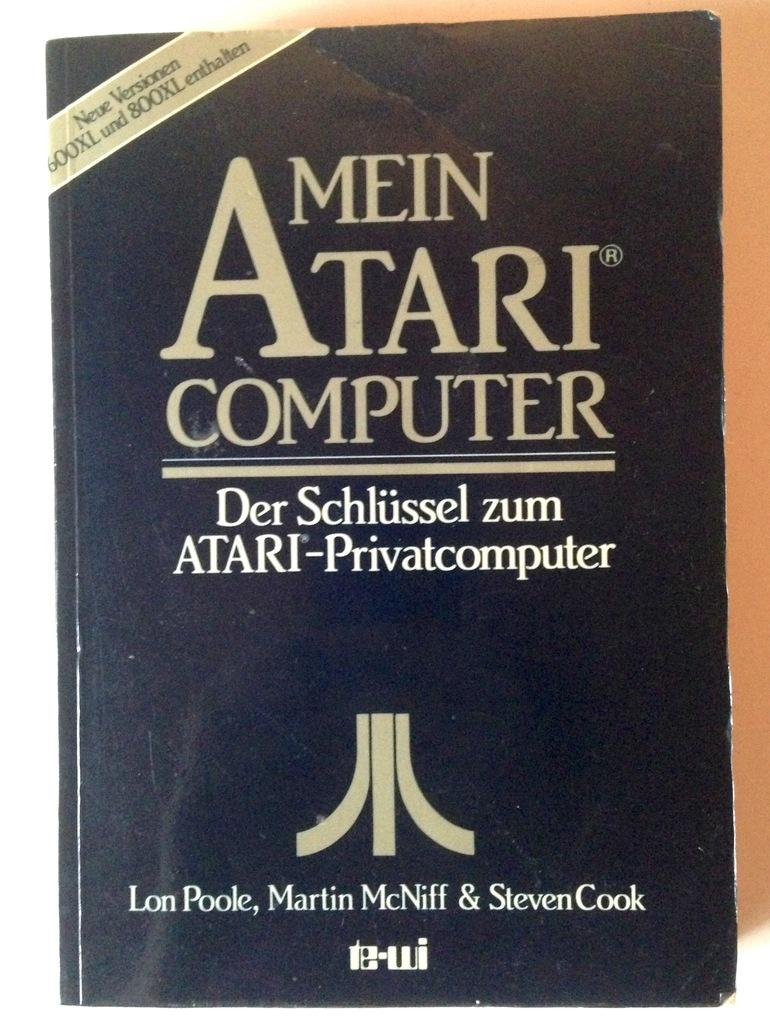<image>
Write a terse but informative summary of the picture. A book with frayed edges says Mein Atari Computer. 